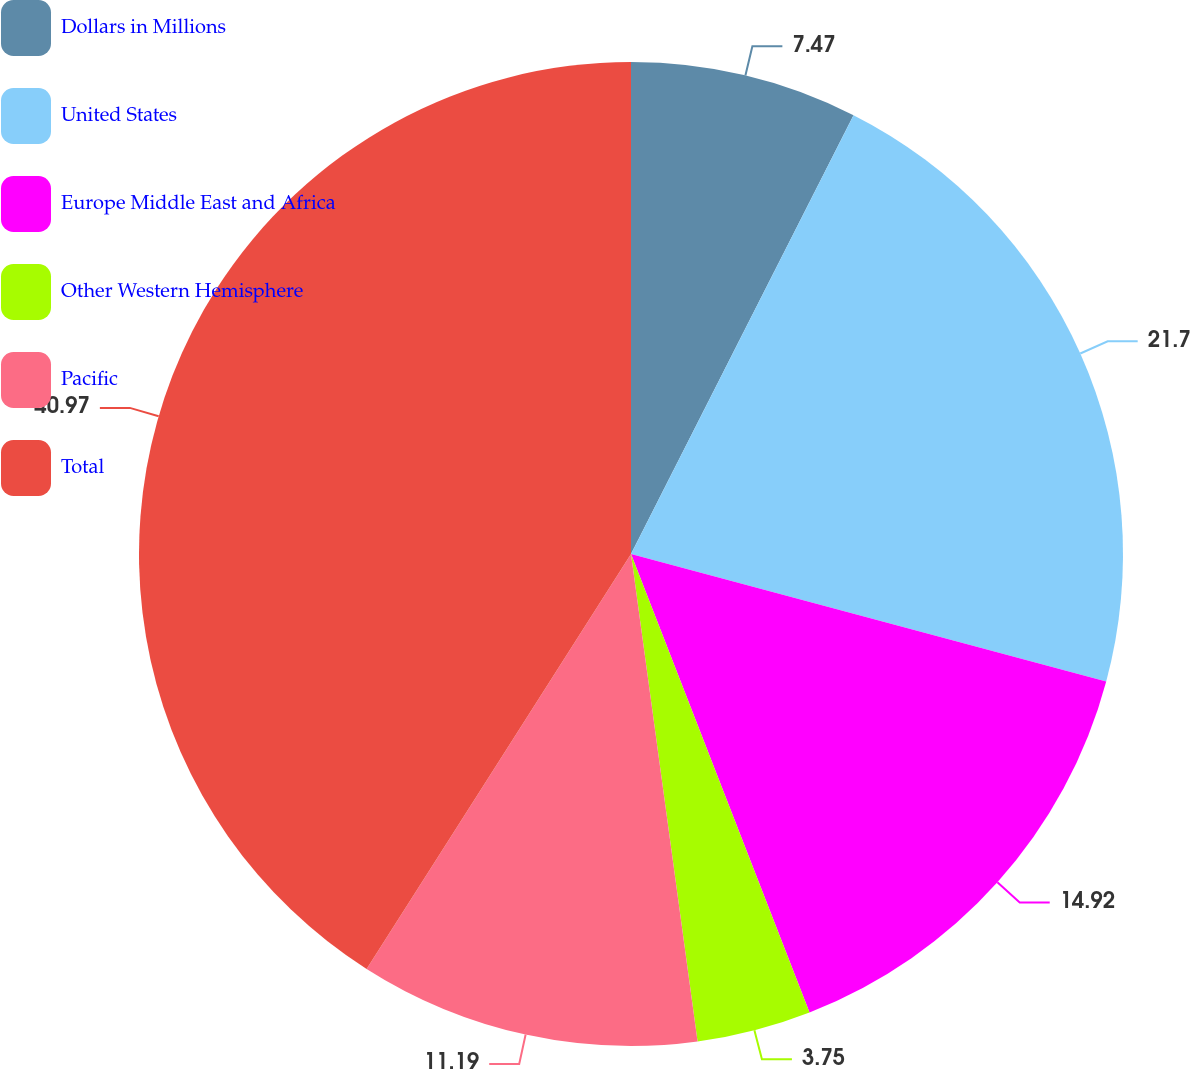Convert chart to OTSL. <chart><loc_0><loc_0><loc_500><loc_500><pie_chart><fcel>Dollars in Millions<fcel>United States<fcel>Europe Middle East and Africa<fcel>Other Western Hemisphere<fcel>Pacific<fcel>Total<nl><fcel>7.47%<fcel>21.7%<fcel>14.92%<fcel>3.75%<fcel>11.19%<fcel>40.97%<nl></chart> 